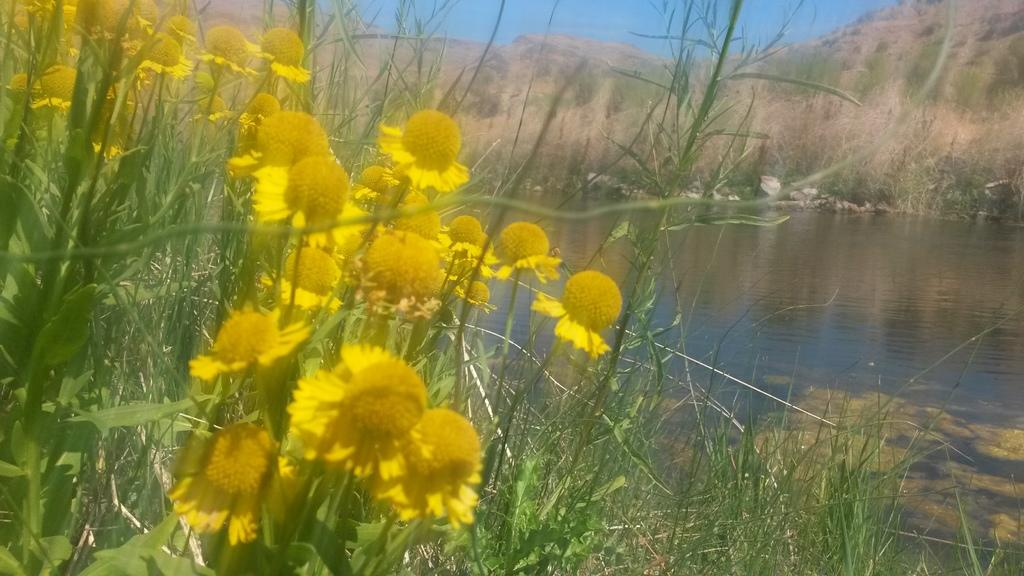What color are the flowers on the plants in the image? The flowers on the plants in the image are yellow. What natural feature can be seen in the image? There is a river visible in the image. What type of vegetation can be seen in the background of the image? There are dry plants on the ground in the background of the image. How many boards are floating in the river in the image? There are no boards present in the image; it only features yellow flowers, a river, and dry plants in the background. 